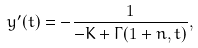Convert formula to latex. <formula><loc_0><loc_0><loc_500><loc_500>y ^ { \prime } ( t ) = - \frac { 1 } { - K + \Gamma ( 1 + n , t ) } ,</formula> 